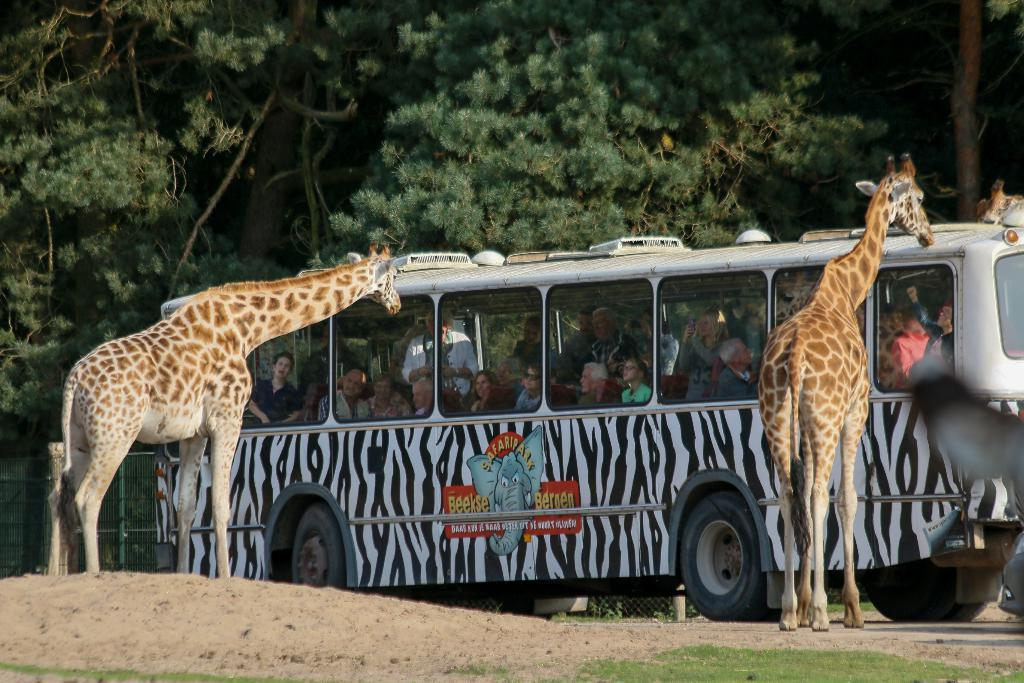What is the main subject of the image? The main subject of the image is a bus. What can be seen inside the bus? There is a group of people in the bus. What animals are present in the image? There are two giraffes standing on the ground. What type of vegetation is visible in the image? There is grass visible in the image. What architectural feature is present in the image? There is a fence in the image. What can be seen in the background of the image? There are trees in the background of the image. What type of drum can be heard playing in the image? There is no drum present in the image, and therefore no sound can be heard. 